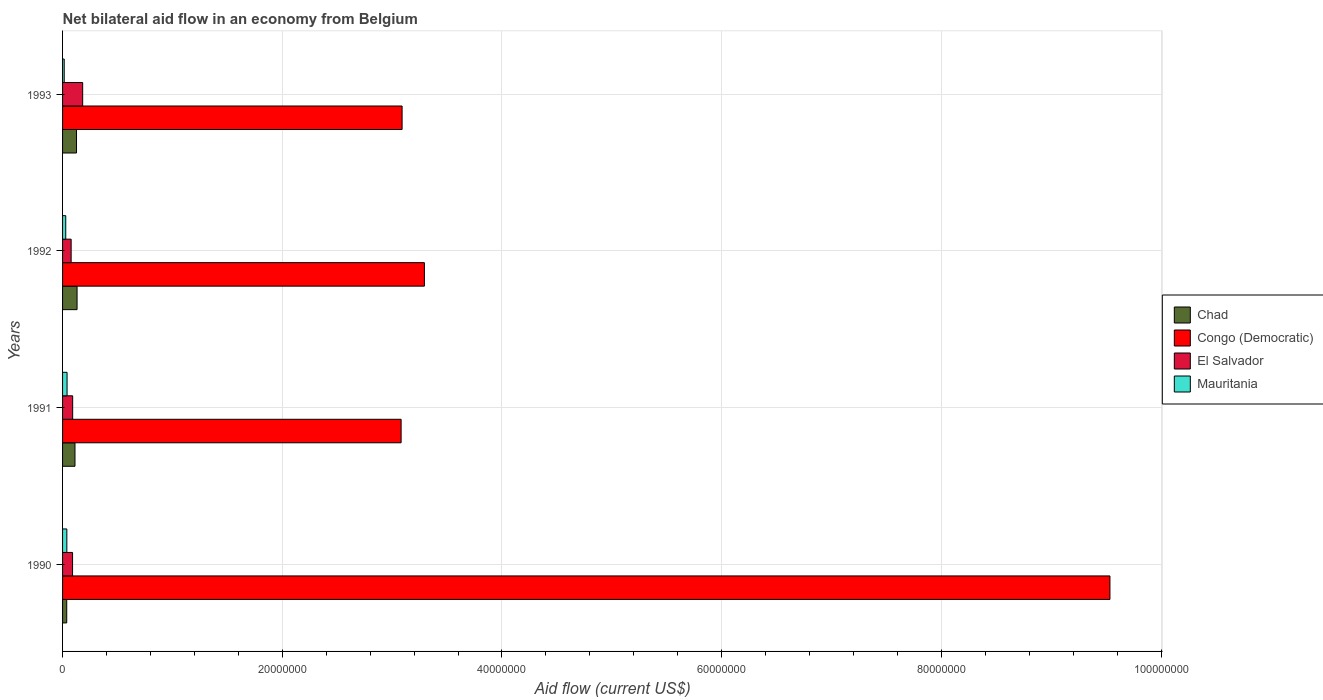How many bars are there on the 4th tick from the bottom?
Ensure brevity in your answer.  4. In how many cases, is the number of bars for a given year not equal to the number of legend labels?
Offer a very short reply. 0. What is the net bilateral aid flow in Chad in 1992?
Your answer should be compact. 1.32e+06. Across all years, what is the minimum net bilateral aid flow in El Salvador?
Ensure brevity in your answer.  7.80e+05. In which year was the net bilateral aid flow in Congo (Democratic) maximum?
Offer a terse response. 1990. In which year was the net bilateral aid flow in El Salvador minimum?
Make the answer very short. 1992. What is the total net bilateral aid flow in Chad in the graph?
Offer a very short reply. 4.10e+06. What is the difference between the net bilateral aid flow in Chad in 1991 and that in 1992?
Keep it short and to the point. -1.90e+05. What is the difference between the net bilateral aid flow in Congo (Democratic) in 1990 and the net bilateral aid flow in Chad in 1992?
Your answer should be compact. 9.40e+07. What is the average net bilateral aid flow in Congo (Democratic) per year?
Offer a terse response. 4.75e+07. In the year 1990, what is the difference between the net bilateral aid flow in Chad and net bilateral aid flow in Congo (Democratic)?
Give a very brief answer. -9.50e+07. In how many years, is the net bilateral aid flow in Mauritania greater than 56000000 US$?
Your response must be concise. 0. What is the ratio of the net bilateral aid flow in El Salvador in 1991 to that in 1993?
Make the answer very short. 0.5. Is the difference between the net bilateral aid flow in Chad in 1991 and 1992 greater than the difference between the net bilateral aid flow in Congo (Democratic) in 1991 and 1992?
Provide a short and direct response. Yes. What is the difference between the highest and the lowest net bilateral aid flow in Congo (Democratic)?
Your response must be concise. 6.45e+07. Is it the case that in every year, the sum of the net bilateral aid flow in Chad and net bilateral aid flow in El Salvador is greater than the sum of net bilateral aid flow in Mauritania and net bilateral aid flow in Congo (Democratic)?
Your response must be concise. No. What does the 1st bar from the top in 1990 represents?
Your response must be concise. Mauritania. What does the 3rd bar from the bottom in 1991 represents?
Your answer should be compact. El Salvador. Are all the bars in the graph horizontal?
Offer a terse response. Yes. Are the values on the major ticks of X-axis written in scientific E-notation?
Offer a very short reply. No. Does the graph contain grids?
Make the answer very short. Yes. How are the legend labels stacked?
Ensure brevity in your answer.  Vertical. What is the title of the graph?
Provide a succinct answer. Net bilateral aid flow in an economy from Belgium. Does "Tajikistan" appear as one of the legend labels in the graph?
Make the answer very short. No. What is the label or title of the Y-axis?
Offer a very short reply. Years. What is the Aid flow (current US$) of Congo (Democratic) in 1990?
Keep it short and to the point. 9.54e+07. What is the Aid flow (current US$) in El Salvador in 1990?
Keep it short and to the point. 9.10e+05. What is the Aid flow (current US$) of Mauritania in 1990?
Your answer should be very brief. 3.90e+05. What is the Aid flow (current US$) in Chad in 1991?
Ensure brevity in your answer.  1.13e+06. What is the Aid flow (current US$) of Congo (Democratic) in 1991?
Make the answer very short. 3.08e+07. What is the Aid flow (current US$) of El Salvador in 1991?
Offer a very short reply. 9.20e+05. What is the Aid flow (current US$) in Chad in 1992?
Provide a succinct answer. 1.32e+06. What is the Aid flow (current US$) of Congo (Democratic) in 1992?
Offer a terse response. 3.29e+07. What is the Aid flow (current US$) of El Salvador in 1992?
Offer a terse response. 7.80e+05. What is the Aid flow (current US$) of Mauritania in 1992?
Keep it short and to the point. 2.90e+05. What is the Aid flow (current US$) of Chad in 1993?
Offer a terse response. 1.27e+06. What is the Aid flow (current US$) in Congo (Democratic) in 1993?
Give a very brief answer. 3.09e+07. What is the Aid flow (current US$) in El Salvador in 1993?
Your response must be concise. 1.83e+06. What is the Aid flow (current US$) in Mauritania in 1993?
Provide a short and direct response. 1.50e+05. Across all years, what is the maximum Aid flow (current US$) of Chad?
Provide a succinct answer. 1.32e+06. Across all years, what is the maximum Aid flow (current US$) in Congo (Democratic)?
Ensure brevity in your answer.  9.54e+07. Across all years, what is the maximum Aid flow (current US$) in El Salvador?
Provide a short and direct response. 1.83e+06. Across all years, what is the maximum Aid flow (current US$) in Mauritania?
Your response must be concise. 4.10e+05. Across all years, what is the minimum Aid flow (current US$) in Chad?
Provide a succinct answer. 3.80e+05. Across all years, what is the minimum Aid flow (current US$) in Congo (Democratic)?
Your response must be concise. 3.08e+07. Across all years, what is the minimum Aid flow (current US$) in El Salvador?
Your answer should be very brief. 7.80e+05. Across all years, what is the minimum Aid flow (current US$) in Mauritania?
Your answer should be compact. 1.50e+05. What is the total Aid flow (current US$) in Chad in the graph?
Make the answer very short. 4.10e+06. What is the total Aid flow (current US$) of Congo (Democratic) in the graph?
Offer a terse response. 1.90e+08. What is the total Aid flow (current US$) in El Salvador in the graph?
Offer a terse response. 4.44e+06. What is the total Aid flow (current US$) in Mauritania in the graph?
Keep it short and to the point. 1.24e+06. What is the difference between the Aid flow (current US$) of Chad in 1990 and that in 1991?
Your answer should be very brief. -7.50e+05. What is the difference between the Aid flow (current US$) in Congo (Democratic) in 1990 and that in 1991?
Offer a very short reply. 6.45e+07. What is the difference between the Aid flow (current US$) of Chad in 1990 and that in 1992?
Provide a succinct answer. -9.40e+05. What is the difference between the Aid flow (current US$) of Congo (Democratic) in 1990 and that in 1992?
Your answer should be very brief. 6.24e+07. What is the difference between the Aid flow (current US$) of El Salvador in 1990 and that in 1992?
Provide a short and direct response. 1.30e+05. What is the difference between the Aid flow (current US$) in Chad in 1990 and that in 1993?
Offer a terse response. -8.90e+05. What is the difference between the Aid flow (current US$) of Congo (Democratic) in 1990 and that in 1993?
Offer a terse response. 6.44e+07. What is the difference between the Aid flow (current US$) of El Salvador in 1990 and that in 1993?
Make the answer very short. -9.20e+05. What is the difference between the Aid flow (current US$) of Congo (Democratic) in 1991 and that in 1992?
Give a very brief answer. -2.12e+06. What is the difference between the Aid flow (current US$) in El Salvador in 1991 and that in 1992?
Your answer should be compact. 1.40e+05. What is the difference between the Aid flow (current US$) of Chad in 1991 and that in 1993?
Give a very brief answer. -1.40e+05. What is the difference between the Aid flow (current US$) of El Salvador in 1991 and that in 1993?
Ensure brevity in your answer.  -9.10e+05. What is the difference between the Aid flow (current US$) of Chad in 1992 and that in 1993?
Keep it short and to the point. 5.00e+04. What is the difference between the Aid flow (current US$) of Congo (Democratic) in 1992 and that in 1993?
Provide a short and direct response. 2.03e+06. What is the difference between the Aid flow (current US$) of El Salvador in 1992 and that in 1993?
Provide a succinct answer. -1.05e+06. What is the difference between the Aid flow (current US$) in Chad in 1990 and the Aid flow (current US$) in Congo (Democratic) in 1991?
Provide a succinct answer. -3.04e+07. What is the difference between the Aid flow (current US$) in Chad in 1990 and the Aid flow (current US$) in El Salvador in 1991?
Your answer should be very brief. -5.40e+05. What is the difference between the Aid flow (current US$) of Congo (Democratic) in 1990 and the Aid flow (current US$) of El Salvador in 1991?
Ensure brevity in your answer.  9.44e+07. What is the difference between the Aid flow (current US$) in Congo (Democratic) in 1990 and the Aid flow (current US$) in Mauritania in 1991?
Give a very brief answer. 9.49e+07. What is the difference between the Aid flow (current US$) in Chad in 1990 and the Aid flow (current US$) in Congo (Democratic) in 1992?
Offer a very short reply. -3.26e+07. What is the difference between the Aid flow (current US$) in Chad in 1990 and the Aid flow (current US$) in El Salvador in 1992?
Your answer should be very brief. -4.00e+05. What is the difference between the Aid flow (current US$) in Chad in 1990 and the Aid flow (current US$) in Mauritania in 1992?
Ensure brevity in your answer.  9.00e+04. What is the difference between the Aid flow (current US$) in Congo (Democratic) in 1990 and the Aid flow (current US$) in El Salvador in 1992?
Provide a succinct answer. 9.46e+07. What is the difference between the Aid flow (current US$) of Congo (Democratic) in 1990 and the Aid flow (current US$) of Mauritania in 1992?
Provide a succinct answer. 9.51e+07. What is the difference between the Aid flow (current US$) in El Salvador in 1990 and the Aid flow (current US$) in Mauritania in 1992?
Offer a very short reply. 6.20e+05. What is the difference between the Aid flow (current US$) in Chad in 1990 and the Aid flow (current US$) in Congo (Democratic) in 1993?
Give a very brief answer. -3.05e+07. What is the difference between the Aid flow (current US$) of Chad in 1990 and the Aid flow (current US$) of El Salvador in 1993?
Ensure brevity in your answer.  -1.45e+06. What is the difference between the Aid flow (current US$) in Congo (Democratic) in 1990 and the Aid flow (current US$) in El Salvador in 1993?
Keep it short and to the point. 9.35e+07. What is the difference between the Aid flow (current US$) of Congo (Democratic) in 1990 and the Aid flow (current US$) of Mauritania in 1993?
Give a very brief answer. 9.52e+07. What is the difference between the Aid flow (current US$) of El Salvador in 1990 and the Aid flow (current US$) of Mauritania in 1993?
Provide a short and direct response. 7.60e+05. What is the difference between the Aid flow (current US$) in Chad in 1991 and the Aid flow (current US$) in Congo (Democratic) in 1992?
Your answer should be compact. -3.18e+07. What is the difference between the Aid flow (current US$) in Chad in 1991 and the Aid flow (current US$) in El Salvador in 1992?
Your response must be concise. 3.50e+05. What is the difference between the Aid flow (current US$) in Chad in 1991 and the Aid flow (current US$) in Mauritania in 1992?
Offer a terse response. 8.40e+05. What is the difference between the Aid flow (current US$) of Congo (Democratic) in 1991 and the Aid flow (current US$) of El Salvador in 1992?
Offer a terse response. 3.00e+07. What is the difference between the Aid flow (current US$) in Congo (Democratic) in 1991 and the Aid flow (current US$) in Mauritania in 1992?
Provide a short and direct response. 3.05e+07. What is the difference between the Aid flow (current US$) in El Salvador in 1991 and the Aid flow (current US$) in Mauritania in 1992?
Give a very brief answer. 6.30e+05. What is the difference between the Aid flow (current US$) in Chad in 1991 and the Aid flow (current US$) in Congo (Democratic) in 1993?
Provide a short and direct response. -2.98e+07. What is the difference between the Aid flow (current US$) in Chad in 1991 and the Aid flow (current US$) in El Salvador in 1993?
Your answer should be very brief. -7.00e+05. What is the difference between the Aid flow (current US$) in Chad in 1991 and the Aid flow (current US$) in Mauritania in 1993?
Provide a short and direct response. 9.80e+05. What is the difference between the Aid flow (current US$) in Congo (Democratic) in 1991 and the Aid flow (current US$) in El Salvador in 1993?
Your answer should be compact. 2.90e+07. What is the difference between the Aid flow (current US$) in Congo (Democratic) in 1991 and the Aid flow (current US$) in Mauritania in 1993?
Provide a succinct answer. 3.07e+07. What is the difference between the Aid flow (current US$) in El Salvador in 1991 and the Aid flow (current US$) in Mauritania in 1993?
Ensure brevity in your answer.  7.70e+05. What is the difference between the Aid flow (current US$) in Chad in 1992 and the Aid flow (current US$) in Congo (Democratic) in 1993?
Ensure brevity in your answer.  -2.96e+07. What is the difference between the Aid flow (current US$) in Chad in 1992 and the Aid flow (current US$) in El Salvador in 1993?
Ensure brevity in your answer.  -5.10e+05. What is the difference between the Aid flow (current US$) of Chad in 1992 and the Aid flow (current US$) of Mauritania in 1993?
Provide a short and direct response. 1.17e+06. What is the difference between the Aid flow (current US$) of Congo (Democratic) in 1992 and the Aid flow (current US$) of El Salvador in 1993?
Offer a very short reply. 3.11e+07. What is the difference between the Aid flow (current US$) of Congo (Democratic) in 1992 and the Aid flow (current US$) of Mauritania in 1993?
Provide a short and direct response. 3.28e+07. What is the difference between the Aid flow (current US$) in El Salvador in 1992 and the Aid flow (current US$) in Mauritania in 1993?
Your response must be concise. 6.30e+05. What is the average Aid flow (current US$) of Chad per year?
Provide a short and direct response. 1.02e+06. What is the average Aid flow (current US$) in Congo (Democratic) per year?
Offer a terse response. 4.75e+07. What is the average Aid flow (current US$) of El Salvador per year?
Offer a very short reply. 1.11e+06. What is the average Aid flow (current US$) in Mauritania per year?
Make the answer very short. 3.10e+05. In the year 1990, what is the difference between the Aid flow (current US$) in Chad and Aid flow (current US$) in Congo (Democratic)?
Make the answer very short. -9.50e+07. In the year 1990, what is the difference between the Aid flow (current US$) of Chad and Aid flow (current US$) of El Salvador?
Make the answer very short. -5.30e+05. In the year 1990, what is the difference between the Aid flow (current US$) of Chad and Aid flow (current US$) of Mauritania?
Offer a very short reply. -10000. In the year 1990, what is the difference between the Aid flow (current US$) of Congo (Democratic) and Aid flow (current US$) of El Salvador?
Your answer should be compact. 9.44e+07. In the year 1990, what is the difference between the Aid flow (current US$) in Congo (Democratic) and Aid flow (current US$) in Mauritania?
Provide a succinct answer. 9.50e+07. In the year 1990, what is the difference between the Aid flow (current US$) of El Salvador and Aid flow (current US$) of Mauritania?
Provide a succinct answer. 5.20e+05. In the year 1991, what is the difference between the Aid flow (current US$) in Chad and Aid flow (current US$) in Congo (Democratic)?
Keep it short and to the point. -2.97e+07. In the year 1991, what is the difference between the Aid flow (current US$) in Chad and Aid flow (current US$) in El Salvador?
Offer a very short reply. 2.10e+05. In the year 1991, what is the difference between the Aid flow (current US$) of Chad and Aid flow (current US$) of Mauritania?
Offer a very short reply. 7.20e+05. In the year 1991, what is the difference between the Aid flow (current US$) in Congo (Democratic) and Aid flow (current US$) in El Salvador?
Offer a very short reply. 2.99e+07. In the year 1991, what is the difference between the Aid flow (current US$) in Congo (Democratic) and Aid flow (current US$) in Mauritania?
Your answer should be very brief. 3.04e+07. In the year 1991, what is the difference between the Aid flow (current US$) in El Salvador and Aid flow (current US$) in Mauritania?
Your response must be concise. 5.10e+05. In the year 1992, what is the difference between the Aid flow (current US$) of Chad and Aid flow (current US$) of Congo (Democratic)?
Ensure brevity in your answer.  -3.16e+07. In the year 1992, what is the difference between the Aid flow (current US$) in Chad and Aid flow (current US$) in El Salvador?
Offer a very short reply. 5.40e+05. In the year 1992, what is the difference between the Aid flow (current US$) in Chad and Aid flow (current US$) in Mauritania?
Your answer should be compact. 1.03e+06. In the year 1992, what is the difference between the Aid flow (current US$) of Congo (Democratic) and Aid flow (current US$) of El Salvador?
Offer a terse response. 3.22e+07. In the year 1992, what is the difference between the Aid flow (current US$) in Congo (Democratic) and Aid flow (current US$) in Mauritania?
Offer a very short reply. 3.26e+07. In the year 1993, what is the difference between the Aid flow (current US$) in Chad and Aid flow (current US$) in Congo (Democratic)?
Ensure brevity in your answer.  -2.96e+07. In the year 1993, what is the difference between the Aid flow (current US$) of Chad and Aid flow (current US$) of El Salvador?
Your answer should be very brief. -5.60e+05. In the year 1993, what is the difference between the Aid flow (current US$) in Chad and Aid flow (current US$) in Mauritania?
Your response must be concise. 1.12e+06. In the year 1993, what is the difference between the Aid flow (current US$) of Congo (Democratic) and Aid flow (current US$) of El Salvador?
Offer a very short reply. 2.91e+07. In the year 1993, what is the difference between the Aid flow (current US$) in Congo (Democratic) and Aid flow (current US$) in Mauritania?
Ensure brevity in your answer.  3.08e+07. In the year 1993, what is the difference between the Aid flow (current US$) in El Salvador and Aid flow (current US$) in Mauritania?
Your response must be concise. 1.68e+06. What is the ratio of the Aid flow (current US$) of Chad in 1990 to that in 1991?
Your answer should be very brief. 0.34. What is the ratio of the Aid flow (current US$) of Congo (Democratic) in 1990 to that in 1991?
Give a very brief answer. 3.09. What is the ratio of the Aid flow (current US$) in El Salvador in 1990 to that in 1991?
Keep it short and to the point. 0.99. What is the ratio of the Aid flow (current US$) in Mauritania in 1990 to that in 1991?
Your answer should be very brief. 0.95. What is the ratio of the Aid flow (current US$) of Chad in 1990 to that in 1992?
Provide a short and direct response. 0.29. What is the ratio of the Aid flow (current US$) in Congo (Democratic) in 1990 to that in 1992?
Ensure brevity in your answer.  2.89. What is the ratio of the Aid flow (current US$) in Mauritania in 1990 to that in 1992?
Make the answer very short. 1.34. What is the ratio of the Aid flow (current US$) in Chad in 1990 to that in 1993?
Keep it short and to the point. 0.3. What is the ratio of the Aid flow (current US$) of Congo (Democratic) in 1990 to that in 1993?
Provide a short and direct response. 3.08. What is the ratio of the Aid flow (current US$) of El Salvador in 1990 to that in 1993?
Your answer should be very brief. 0.5. What is the ratio of the Aid flow (current US$) of Chad in 1991 to that in 1992?
Your response must be concise. 0.86. What is the ratio of the Aid flow (current US$) of Congo (Democratic) in 1991 to that in 1992?
Your answer should be very brief. 0.94. What is the ratio of the Aid flow (current US$) in El Salvador in 1991 to that in 1992?
Provide a short and direct response. 1.18. What is the ratio of the Aid flow (current US$) in Mauritania in 1991 to that in 1992?
Provide a short and direct response. 1.41. What is the ratio of the Aid flow (current US$) in Chad in 1991 to that in 1993?
Provide a short and direct response. 0.89. What is the ratio of the Aid flow (current US$) in Congo (Democratic) in 1991 to that in 1993?
Ensure brevity in your answer.  1. What is the ratio of the Aid flow (current US$) of El Salvador in 1991 to that in 1993?
Keep it short and to the point. 0.5. What is the ratio of the Aid flow (current US$) of Mauritania in 1991 to that in 1993?
Your response must be concise. 2.73. What is the ratio of the Aid flow (current US$) of Chad in 1992 to that in 1993?
Offer a terse response. 1.04. What is the ratio of the Aid flow (current US$) of Congo (Democratic) in 1992 to that in 1993?
Your answer should be compact. 1.07. What is the ratio of the Aid flow (current US$) in El Salvador in 1992 to that in 1993?
Provide a short and direct response. 0.43. What is the ratio of the Aid flow (current US$) of Mauritania in 1992 to that in 1993?
Your answer should be very brief. 1.93. What is the difference between the highest and the second highest Aid flow (current US$) in Chad?
Your answer should be very brief. 5.00e+04. What is the difference between the highest and the second highest Aid flow (current US$) in Congo (Democratic)?
Your response must be concise. 6.24e+07. What is the difference between the highest and the second highest Aid flow (current US$) in El Salvador?
Your answer should be very brief. 9.10e+05. What is the difference between the highest and the lowest Aid flow (current US$) of Chad?
Make the answer very short. 9.40e+05. What is the difference between the highest and the lowest Aid flow (current US$) of Congo (Democratic)?
Offer a terse response. 6.45e+07. What is the difference between the highest and the lowest Aid flow (current US$) of El Salvador?
Your response must be concise. 1.05e+06. 